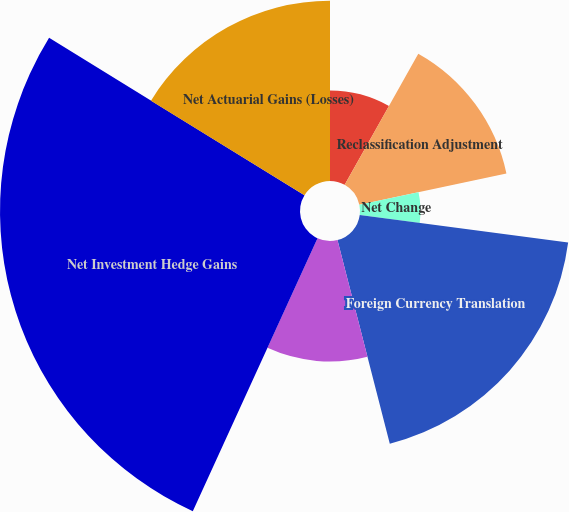Convert chart. <chart><loc_0><loc_0><loc_500><loc_500><pie_chart><fcel>Unrealized (Losses) Gains on<fcel>Reclassification Adjustment<fcel>Net Change<fcel>Foreign Currency Translation<fcel>Long-Term Intra-Entity Foreign<fcel>Net Investment Hedge Gains<fcel>Net Actuarial Gains (Losses)<nl><fcel>8.14%<fcel>13.52%<fcel>5.44%<fcel>18.9%<fcel>10.83%<fcel>26.97%<fcel>16.21%<nl></chart> 